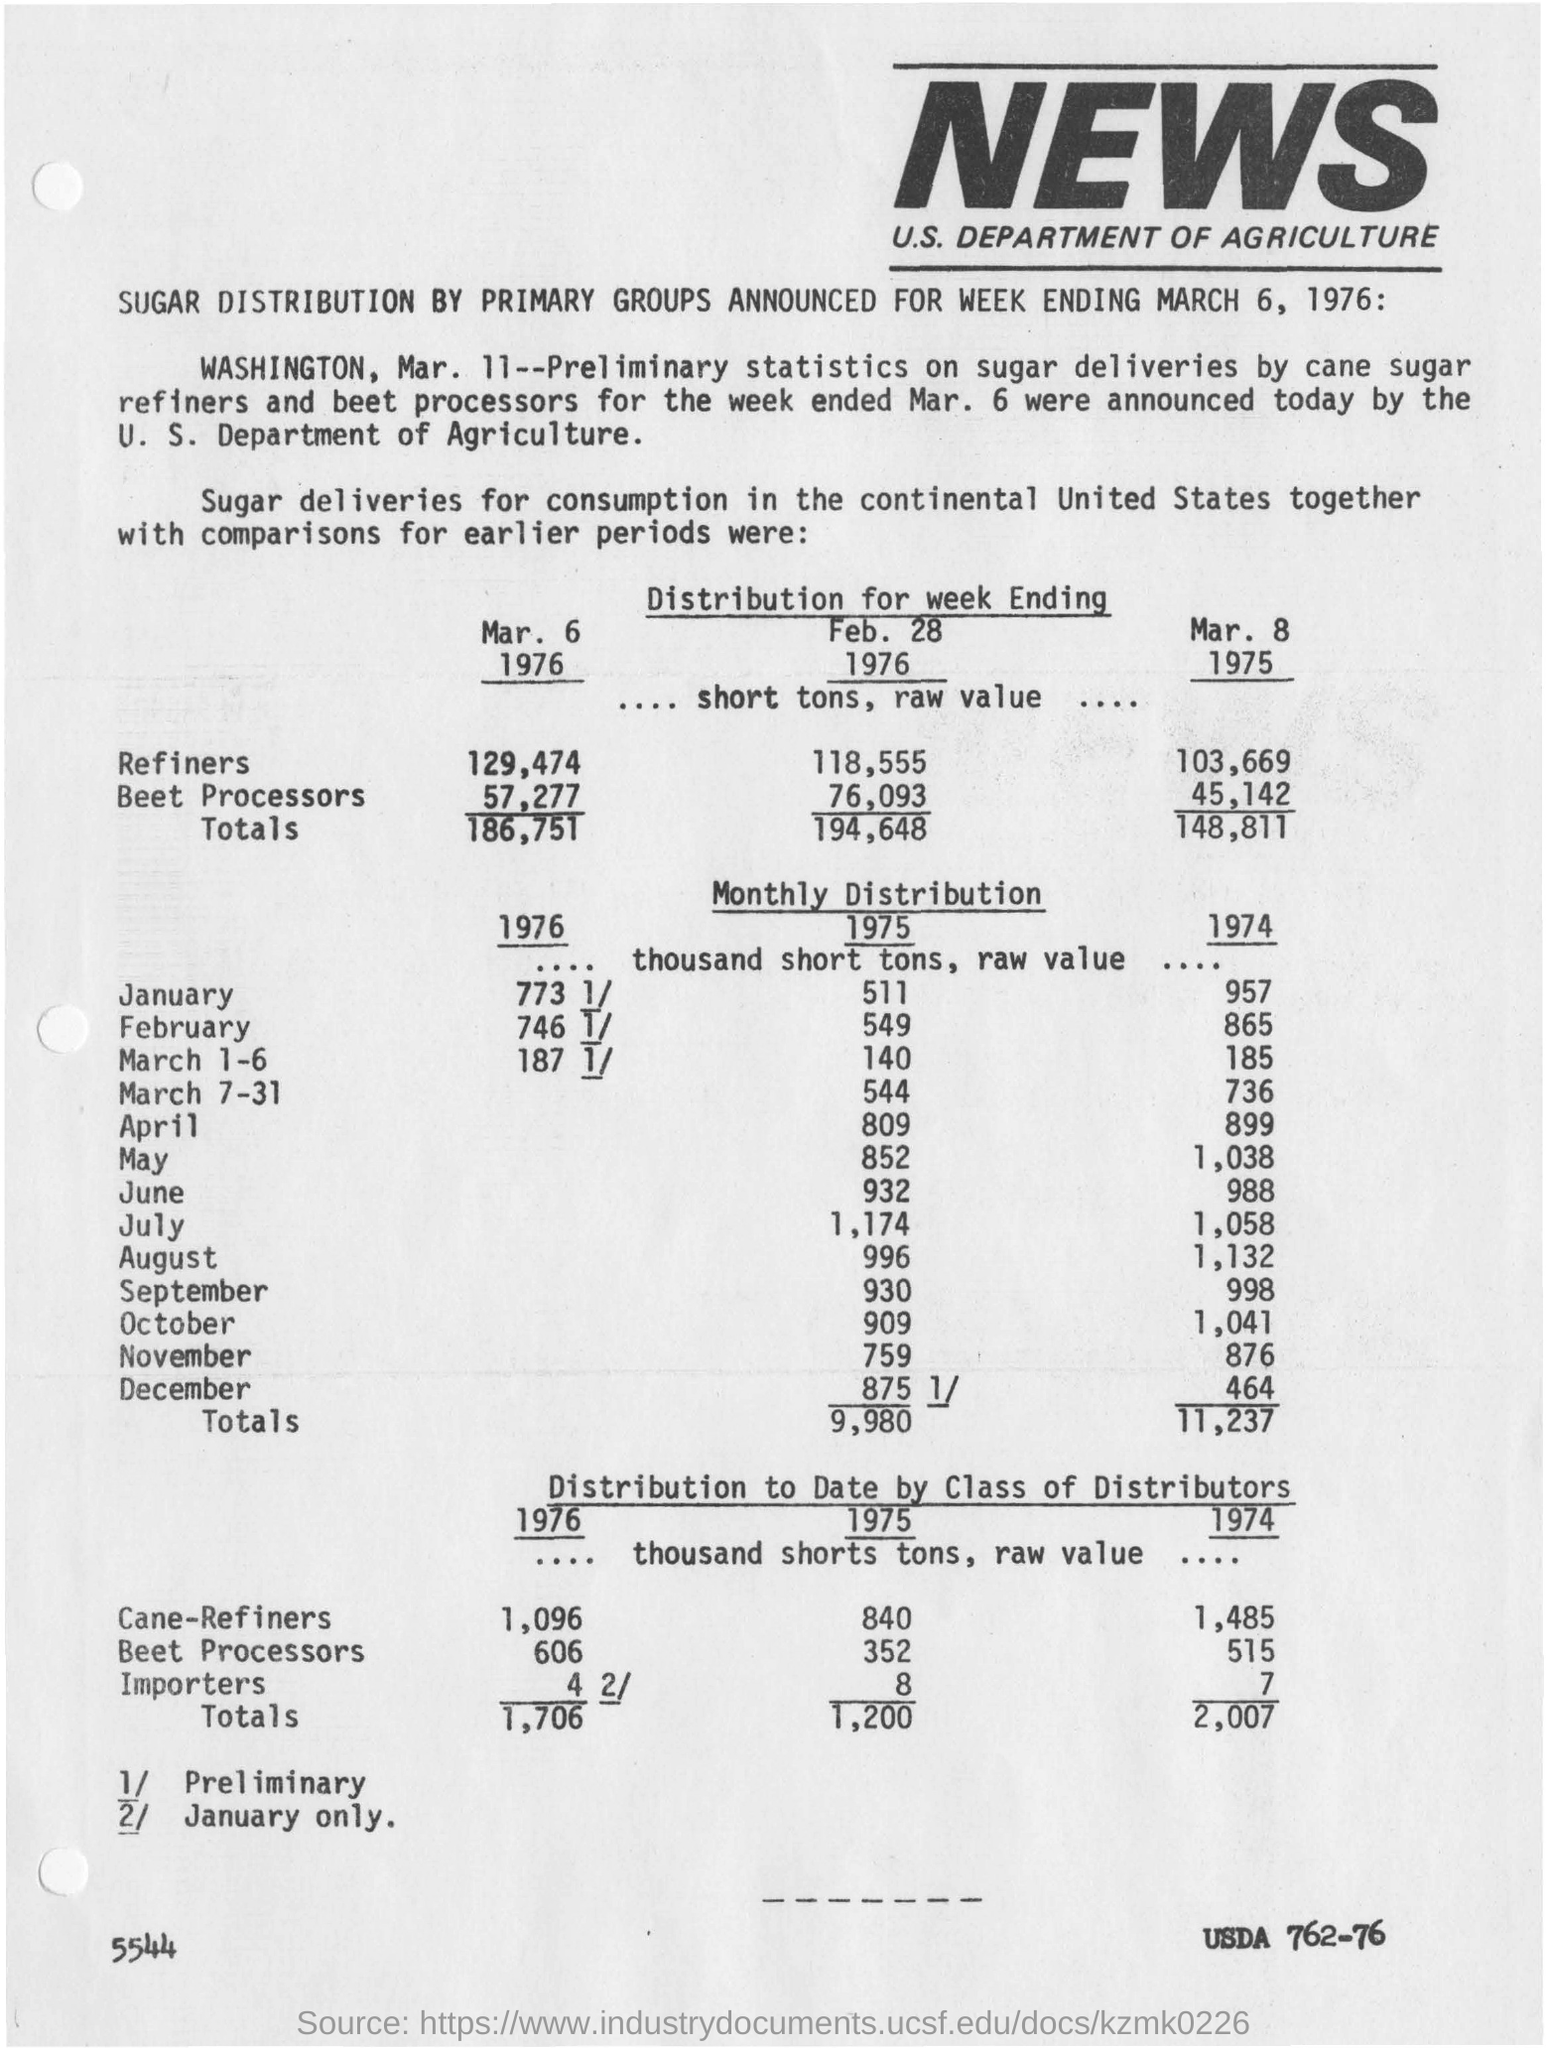News coverage is for which country?
Keep it short and to the point. U.S. What is the value of importers for the year 1975?
Provide a short and direct response. 8. The article mentions the distribution of which product?
Provide a short and direct response. Sugar. 